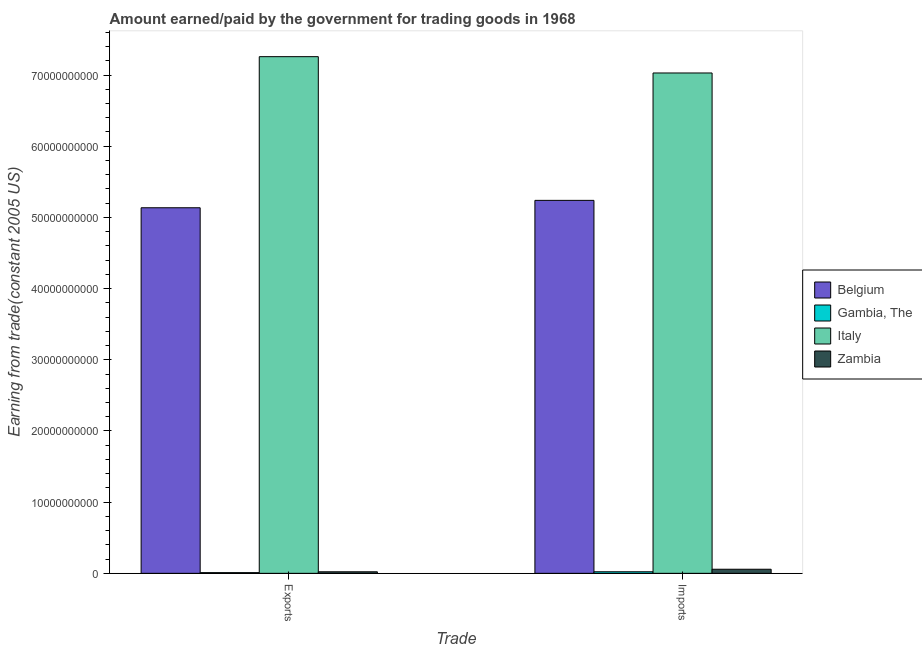How many groups of bars are there?
Provide a short and direct response. 2. Are the number of bars per tick equal to the number of legend labels?
Your response must be concise. Yes. How many bars are there on the 1st tick from the left?
Your response must be concise. 4. What is the label of the 2nd group of bars from the left?
Give a very brief answer. Imports. What is the amount earned from exports in Italy?
Make the answer very short. 7.26e+1. Across all countries, what is the maximum amount earned from exports?
Provide a succinct answer. 7.26e+1. Across all countries, what is the minimum amount earned from exports?
Make the answer very short. 9.78e+07. In which country was the amount earned from exports maximum?
Offer a terse response. Italy. In which country was the amount earned from exports minimum?
Your answer should be compact. Gambia, The. What is the total amount earned from exports in the graph?
Offer a terse response. 1.24e+11. What is the difference between the amount earned from exports in Italy and that in Belgium?
Make the answer very short. 2.12e+1. What is the difference between the amount earned from exports in Gambia, The and the amount paid for imports in Belgium?
Your answer should be very brief. -5.23e+1. What is the average amount paid for imports per country?
Offer a terse response. 3.09e+1. What is the difference between the amount earned from exports and amount paid for imports in Belgium?
Provide a short and direct response. -1.04e+09. What is the ratio of the amount paid for imports in Gambia, The to that in Belgium?
Offer a terse response. 0. Is the amount earned from exports in Italy less than that in Belgium?
Give a very brief answer. No. What does the 2nd bar from the left in Exports represents?
Ensure brevity in your answer.  Gambia, The. Does the graph contain any zero values?
Provide a succinct answer. No. Where does the legend appear in the graph?
Provide a succinct answer. Center right. How are the legend labels stacked?
Give a very brief answer. Vertical. What is the title of the graph?
Your answer should be compact. Amount earned/paid by the government for trading goods in 1968. Does "Kosovo" appear as one of the legend labels in the graph?
Provide a short and direct response. No. What is the label or title of the X-axis?
Your response must be concise. Trade. What is the label or title of the Y-axis?
Your response must be concise. Earning from trade(constant 2005 US). What is the Earning from trade(constant 2005 US) of Belgium in Exports?
Ensure brevity in your answer.  5.14e+1. What is the Earning from trade(constant 2005 US) of Gambia, The in Exports?
Offer a terse response. 9.78e+07. What is the Earning from trade(constant 2005 US) in Italy in Exports?
Provide a short and direct response. 7.26e+1. What is the Earning from trade(constant 2005 US) of Zambia in Exports?
Offer a very short reply. 2.17e+08. What is the Earning from trade(constant 2005 US) of Belgium in Imports?
Keep it short and to the point. 5.24e+1. What is the Earning from trade(constant 2005 US) in Gambia, The in Imports?
Make the answer very short. 2.18e+08. What is the Earning from trade(constant 2005 US) in Italy in Imports?
Give a very brief answer. 7.03e+1. What is the Earning from trade(constant 2005 US) in Zambia in Imports?
Provide a succinct answer. 5.74e+08. Across all Trade, what is the maximum Earning from trade(constant 2005 US) of Belgium?
Ensure brevity in your answer.  5.24e+1. Across all Trade, what is the maximum Earning from trade(constant 2005 US) of Gambia, The?
Ensure brevity in your answer.  2.18e+08. Across all Trade, what is the maximum Earning from trade(constant 2005 US) of Italy?
Make the answer very short. 7.26e+1. Across all Trade, what is the maximum Earning from trade(constant 2005 US) of Zambia?
Keep it short and to the point. 5.74e+08. Across all Trade, what is the minimum Earning from trade(constant 2005 US) in Belgium?
Keep it short and to the point. 5.14e+1. Across all Trade, what is the minimum Earning from trade(constant 2005 US) in Gambia, The?
Your answer should be very brief. 9.78e+07. Across all Trade, what is the minimum Earning from trade(constant 2005 US) in Italy?
Offer a terse response. 7.03e+1. Across all Trade, what is the minimum Earning from trade(constant 2005 US) of Zambia?
Your answer should be very brief. 2.17e+08. What is the total Earning from trade(constant 2005 US) of Belgium in the graph?
Offer a terse response. 1.04e+11. What is the total Earning from trade(constant 2005 US) of Gambia, The in the graph?
Offer a terse response. 3.16e+08. What is the total Earning from trade(constant 2005 US) of Italy in the graph?
Provide a short and direct response. 1.43e+11. What is the total Earning from trade(constant 2005 US) of Zambia in the graph?
Make the answer very short. 7.91e+08. What is the difference between the Earning from trade(constant 2005 US) of Belgium in Exports and that in Imports?
Offer a very short reply. -1.04e+09. What is the difference between the Earning from trade(constant 2005 US) in Gambia, The in Exports and that in Imports?
Make the answer very short. -1.20e+08. What is the difference between the Earning from trade(constant 2005 US) of Italy in Exports and that in Imports?
Offer a very short reply. 2.29e+09. What is the difference between the Earning from trade(constant 2005 US) in Zambia in Exports and that in Imports?
Your response must be concise. -3.57e+08. What is the difference between the Earning from trade(constant 2005 US) in Belgium in Exports and the Earning from trade(constant 2005 US) in Gambia, The in Imports?
Ensure brevity in your answer.  5.11e+1. What is the difference between the Earning from trade(constant 2005 US) of Belgium in Exports and the Earning from trade(constant 2005 US) of Italy in Imports?
Your answer should be very brief. -1.89e+1. What is the difference between the Earning from trade(constant 2005 US) in Belgium in Exports and the Earning from trade(constant 2005 US) in Zambia in Imports?
Provide a succinct answer. 5.08e+1. What is the difference between the Earning from trade(constant 2005 US) in Gambia, The in Exports and the Earning from trade(constant 2005 US) in Italy in Imports?
Provide a succinct answer. -7.02e+1. What is the difference between the Earning from trade(constant 2005 US) of Gambia, The in Exports and the Earning from trade(constant 2005 US) of Zambia in Imports?
Ensure brevity in your answer.  -4.76e+08. What is the difference between the Earning from trade(constant 2005 US) of Italy in Exports and the Earning from trade(constant 2005 US) of Zambia in Imports?
Give a very brief answer. 7.20e+1. What is the average Earning from trade(constant 2005 US) in Belgium per Trade?
Your answer should be compact. 5.19e+1. What is the average Earning from trade(constant 2005 US) in Gambia, The per Trade?
Keep it short and to the point. 1.58e+08. What is the average Earning from trade(constant 2005 US) in Italy per Trade?
Provide a short and direct response. 7.14e+1. What is the average Earning from trade(constant 2005 US) of Zambia per Trade?
Your answer should be compact. 3.95e+08. What is the difference between the Earning from trade(constant 2005 US) in Belgium and Earning from trade(constant 2005 US) in Gambia, The in Exports?
Keep it short and to the point. 5.13e+1. What is the difference between the Earning from trade(constant 2005 US) of Belgium and Earning from trade(constant 2005 US) of Italy in Exports?
Keep it short and to the point. -2.12e+1. What is the difference between the Earning from trade(constant 2005 US) of Belgium and Earning from trade(constant 2005 US) of Zambia in Exports?
Give a very brief answer. 5.11e+1. What is the difference between the Earning from trade(constant 2005 US) of Gambia, The and Earning from trade(constant 2005 US) of Italy in Exports?
Give a very brief answer. -7.25e+1. What is the difference between the Earning from trade(constant 2005 US) in Gambia, The and Earning from trade(constant 2005 US) in Zambia in Exports?
Provide a succinct answer. -1.19e+08. What is the difference between the Earning from trade(constant 2005 US) in Italy and Earning from trade(constant 2005 US) in Zambia in Exports?
Your answer should be compact. 7.24e+1. What is the difference between the Earning from trade(constant 2005 US) of Belgium and Earning from trade(constant 2005 US) of Gambia, The in Imports?
Keep it short and to the point. 5.22e+1. What is the difference between the Earning from trade(constant 2005 US) in Belgium and Earning from trade(constant 2005 US) in Italy in Imports?
Ensure brevity in your answer.  -1.79e+1. What is the difference between the Earning from trade(constant 2005 US) in Belgium and Earning from trade(constant 2005 US) in Zambia in Imports?
Provide a short and direct response. 5.18e+1. What is the difference between the Earning from trade(constant 2005 US) of Gambia, The and Earning from trade(constant 2005 US) of Italy in Imports?
Provide a succinct answer. -7.01e+1. What is the difference between the Earning from trade(constant 2005 US) in Gambia, The and Earning from trade(constant 2005 US) in Zambia in Imports?
Provide a short and direct response. -3.56e+08. What is the difference between the Earning from trade(constant 2005 US) of Italy and Earning from trade(constant 2005 US) of Zambia in Imports?
Provide a succinct answer. 6.97e+1. What is the ratio of the Earning from trade(constant 2005 US) in Belgium in Exports to that in Imports?
Offer a very short reply. 0.98. What is the ratio of the Earning from trade(constant 2005 US) of Gambia, The in Exports to that in Imports?
Offer a very short reply. 0.45. What is the ratio of the Earning from trade(constant 2005 US) in Italy in Exports to that in Imports?
Your response must be concise. 1.03. What is the ratio of the Earning from trade(constant 2005 US) in Zambia in Exports to that in Imports?
Ensure brevity in your answer.  0.38. What is the difference between the highest and the second highest Earning from trade(constant 2005 US) in Belgium?
Make the answer very short. 1.04e+09. What is the difference between the highest and the second highest Earning from trade(constant 2005 US) of Gambia, The?
Give a very brief answer. 1.20e+08. What is the difference between the highest and the second highest Earning from trade(constant 2005 US) in Italy?
Make the answer very short. 2.29e+09. What is the difference between the highest and the second highest Earning from trade(constant 2005 US) in Zambia?
Give a very brief answer. 3.57e+08. What is the difference between the highest and the lowest Earning from trade(constant 2005 US) in Belgium?
Make the answer very short. 1.04e+09. What is the difference between the highest and the lowest Earning from trade(constant 2005 US) in Gambia, The?
Provide a succinct answer. 1.20e+08. What is the difference between the highest and the lowest Earning from trade(constant 2005 US) of Italy?
Your answer should be very brief. 2.29e+09. What is the difference between the highest and the lowest Earning from trade(constant 2005 US) in Zambia?
Keep it short and to the point. 3.57e+08. 